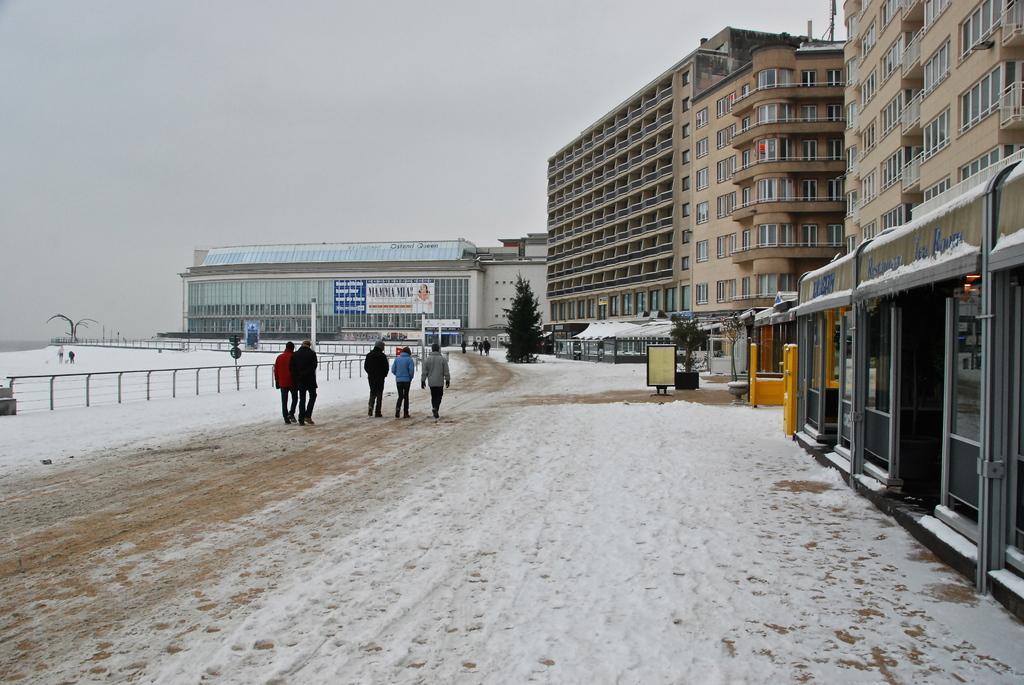How would you summarize this image in a sentence or two? People are walking. There is fencing and snow. There are building. 